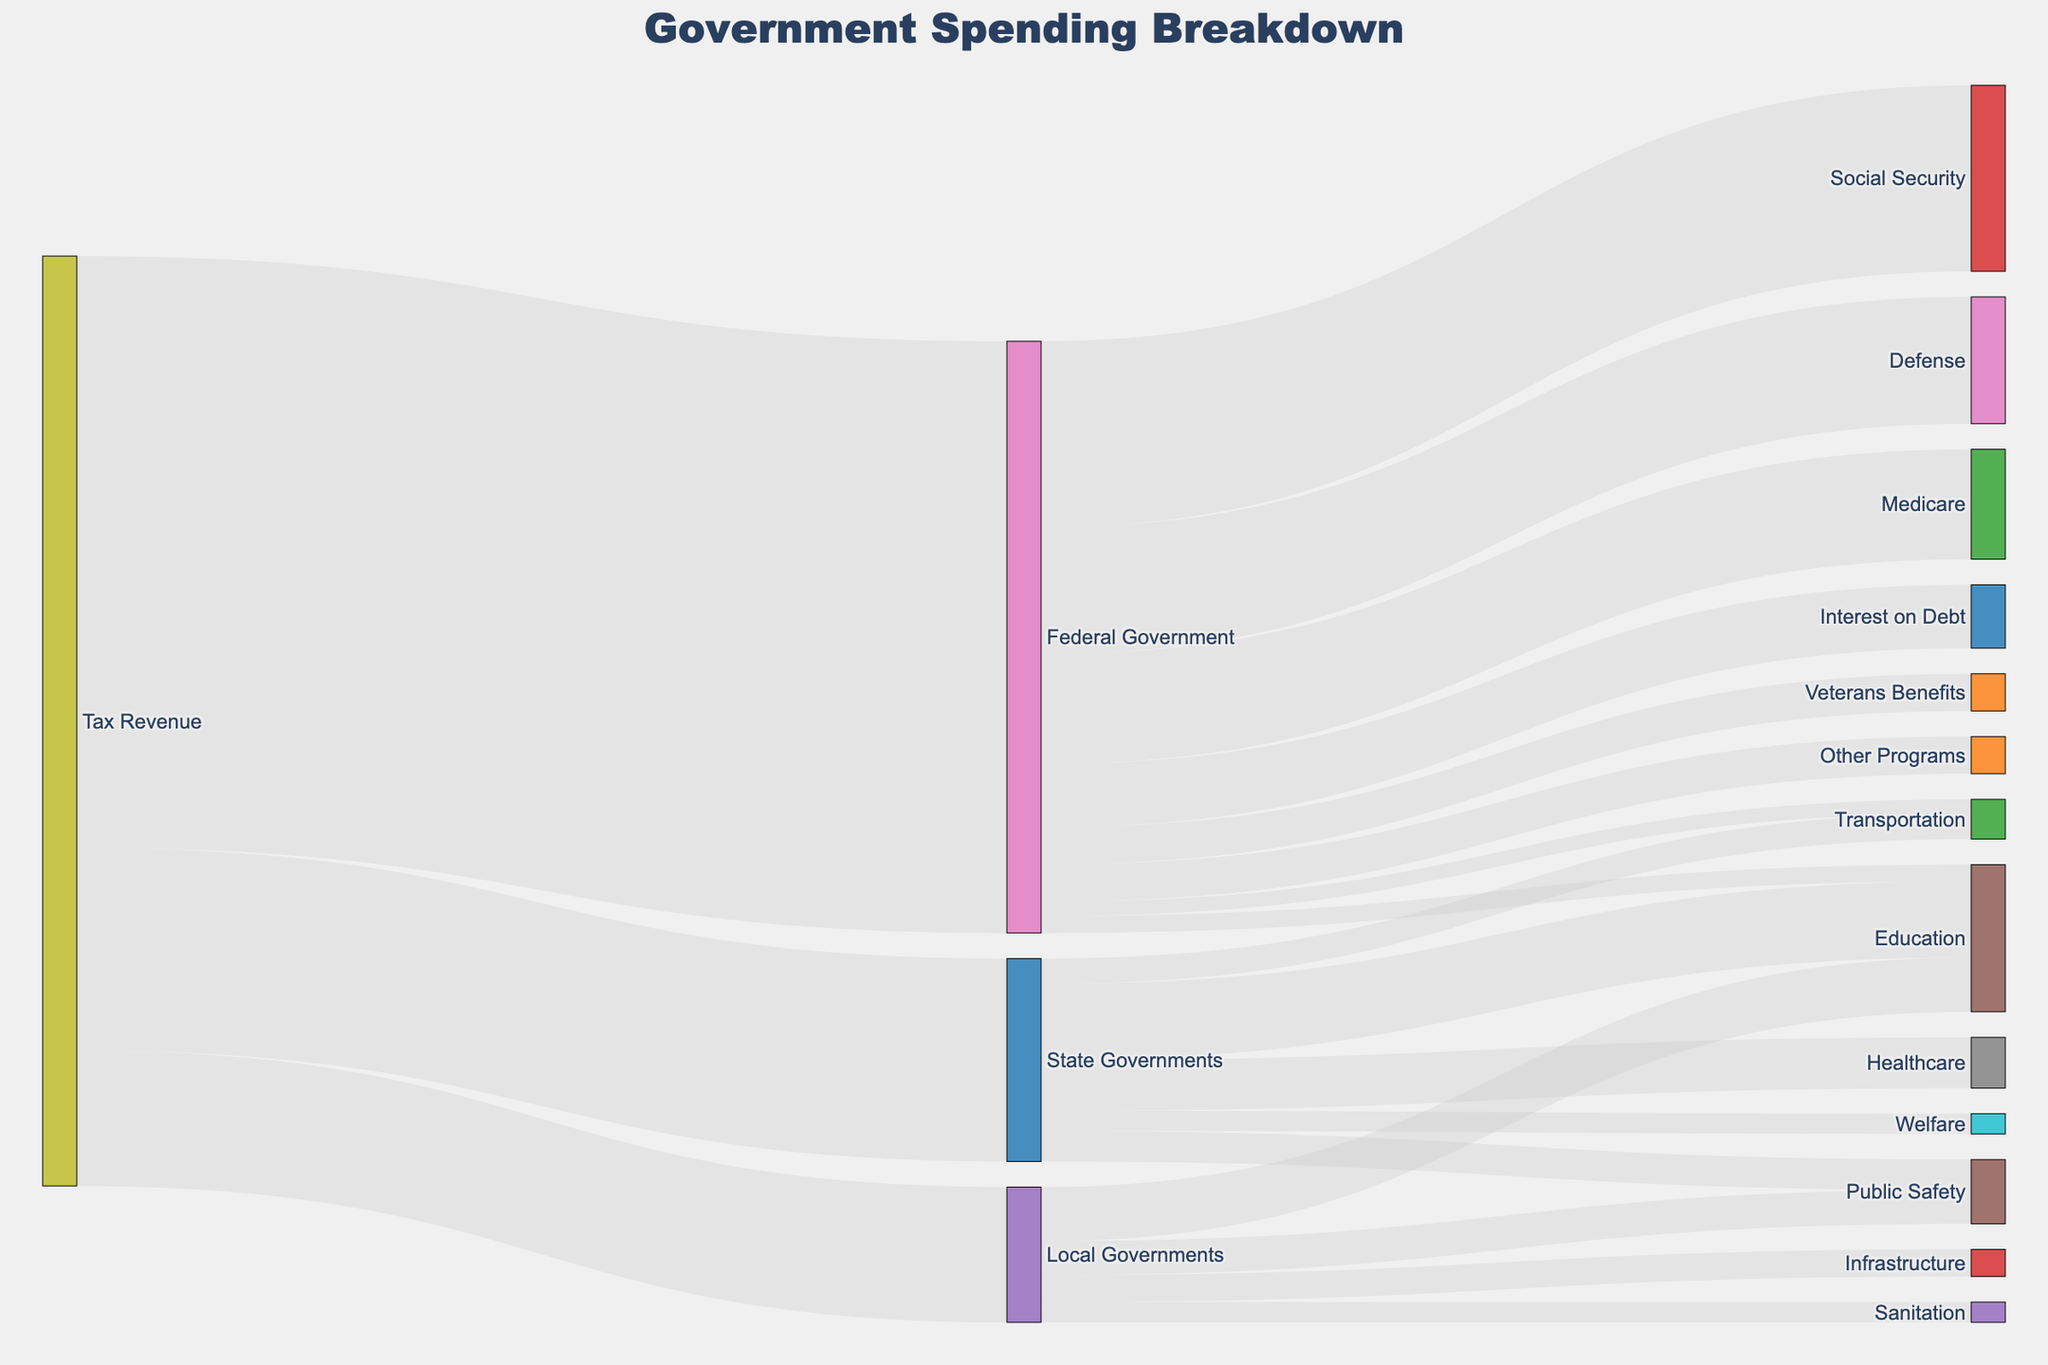what is the total tax revenue collected? To find the total tax revenue collected, sum up the values going into the categories: Federal Government (3,500), State Governments (1,200), and Local Governments (800). The total is 3,500 + 1,200 + 800.
Answer: 5,500 Which sector receives the highest allocation from the Federal Government? Look for the sector with the highest value connected to the 'Federal Government' node. The sectors and their values are: Defense (750), Social Security (1,100), Medicare (650), Interest on Debt (375), Education (100), Transportation (85), Veterans Benefits (220), and Other Programs (220). 'Social Security' has the highest value at 1,100.
Answer: Social Security What is the combined spending on 'Education' by all levels of government? Combine the values allocated to 'Education' from Federal, State, and Local Governments. The values are: Federal Government (100), State Governments (450), and Local Governments (320). The total is 100 + 450 + 320.
Answer: 870 Which government level spends the most on 'Public Safety'? Compare the spending on 'Public Safety' by State and Local Governments. State Governments allocate 180, while Local Governments allocate 200. Local Governments spend more.
Answer: Local Governments How much more does the Federal Government spend on 'Medicare' compared to 'Veterans Benefits'? Find the difference between the spending on 'Medicare' (650) and 'Veterans Benefits' (220). The calculation is 650 - 220.
Answer: 430 What is the total spending by the Federal Government? Add up the values allocated to all sectors from the 'Federal Government' node: Defense (750), Social Security (1,100), Medicare (650), Interest on Debt (375), Education (100), Transportation (85), Veterans Benefits (220), and Other Programs (220). The total is 750 + 1,100 + 650 + 375 + 100 + 85 + 220 + 220.
Answer: 3,500 Which sector receives the least funding from the State Governments? Identify the sector with the smallest value connected to 'State Governments'. The sectors and their values are: Education (450), Healthcare (300), Transportation (150), Public Safety (180), and Welfare (120). 'Welfare' receives the least with 120.
Answer: Welfare How does 'Transportation' funding from the Federal Government compare to that from the State Governments? Observe the funding values for 'Transportation' from Federal (85) and State Governments (150). Federal Government spends less.
Answer: State Governments spend more How much do Local Governments spend on 'Sanitation'? Look for the value connected to 'Sanitation' from 'Local Governments'. The value is 120.
Answer: 120 